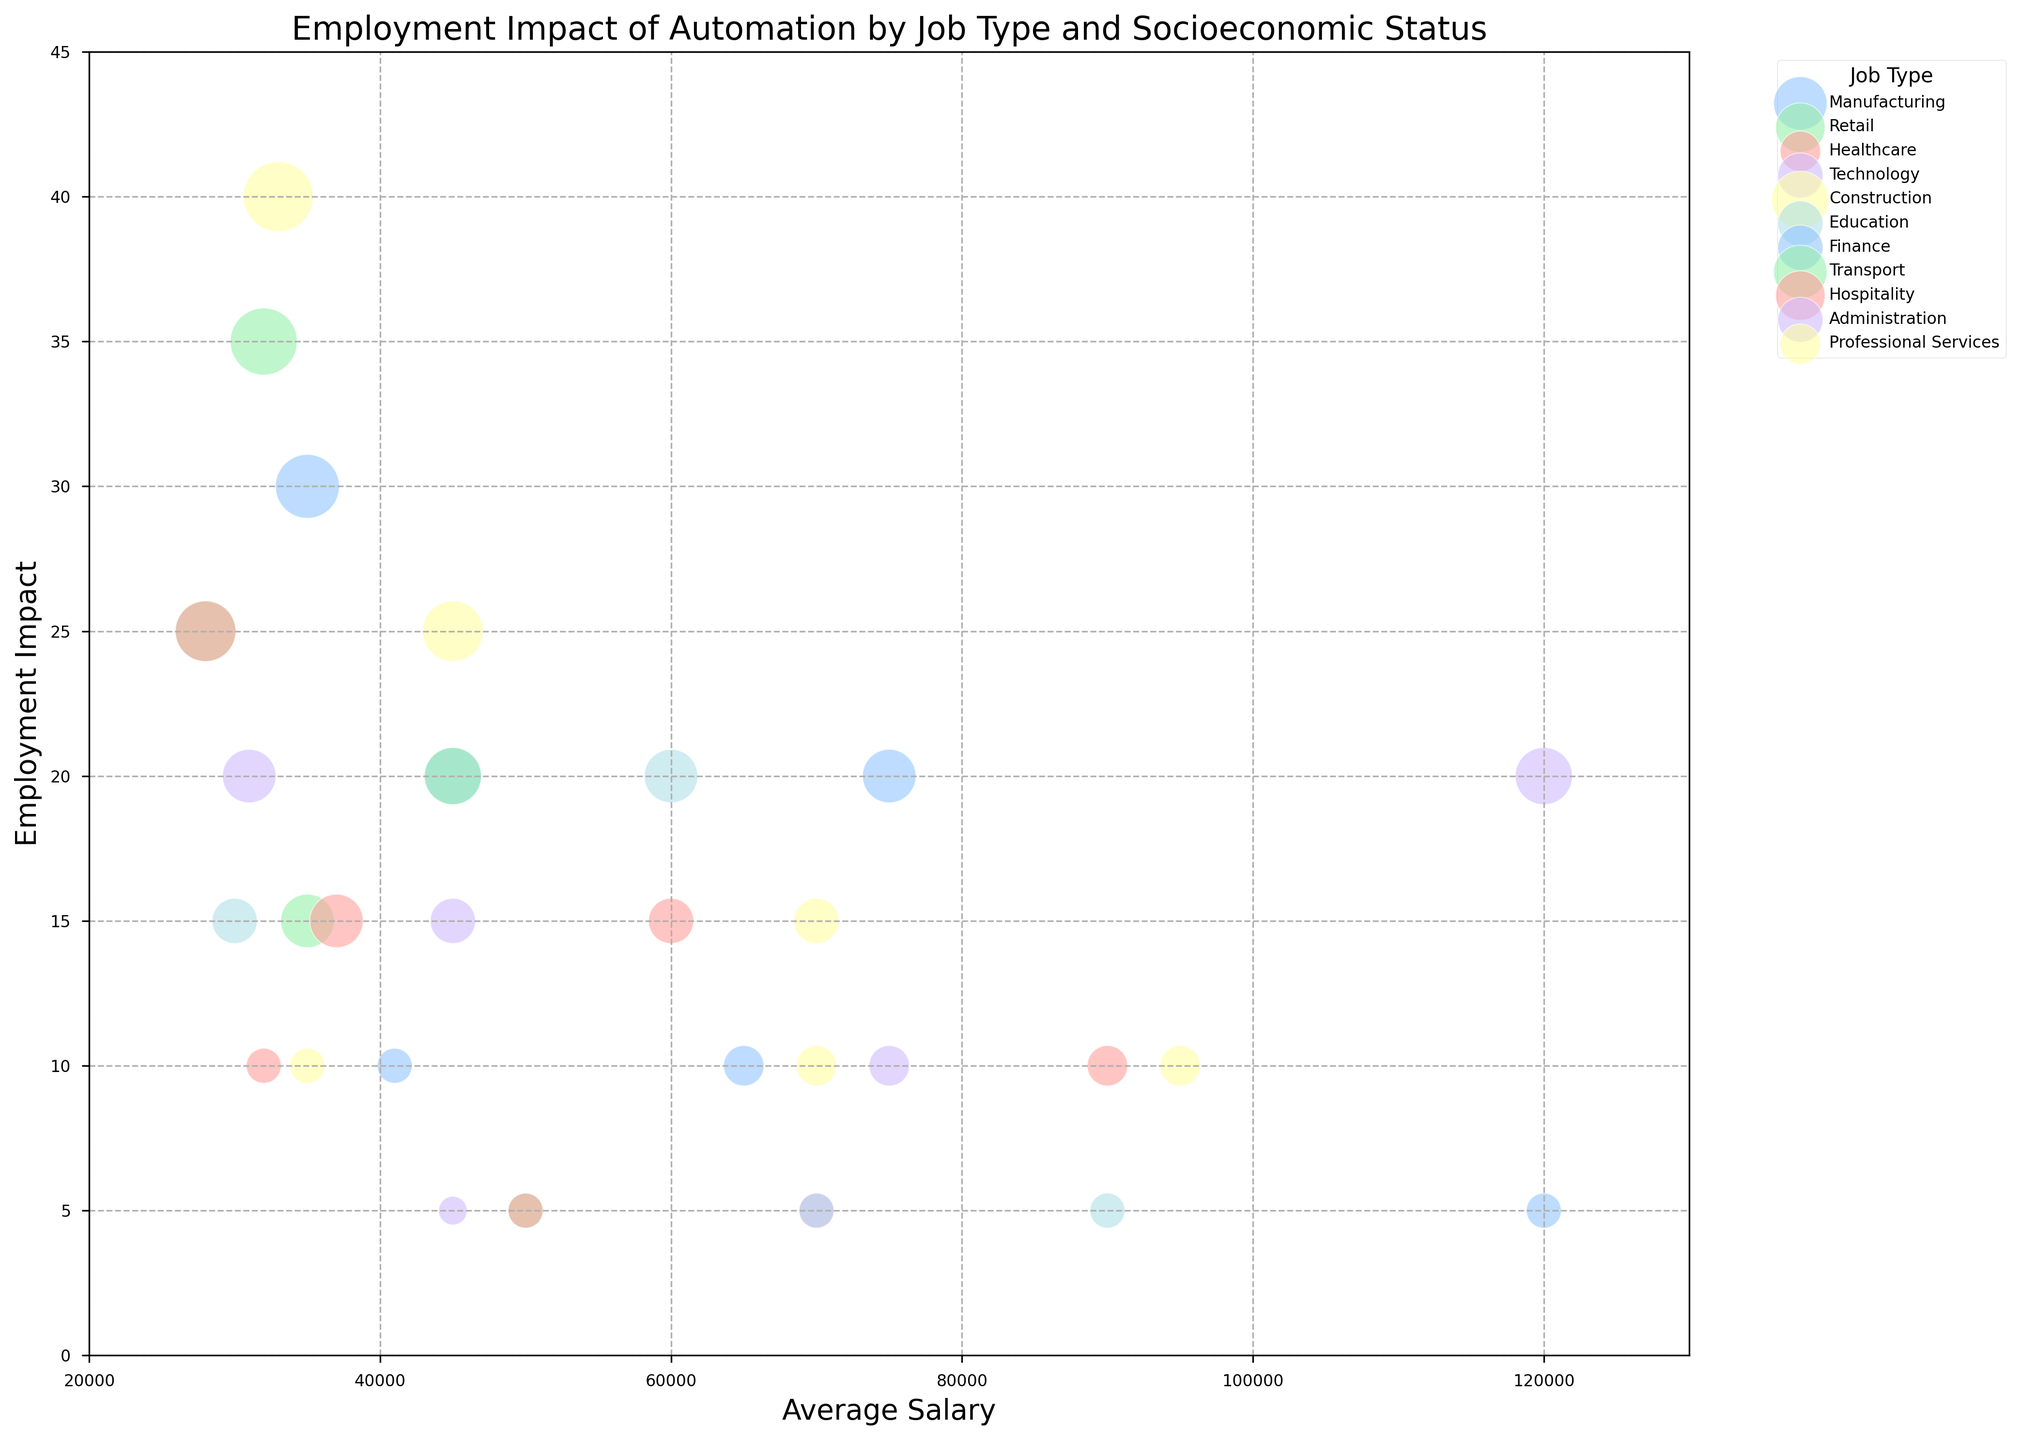Which job type has the highest employment impact overall? By visually examining the highest points on the y-axis, we observe that "Construction" has the highest employment impact at 40 for the Low socioeconomic status group.
Answer: Construction For the Low socioeconomic status groups, which job type has the largest bubble size, indicating the number of people employed in that sector? By comparing the bubble sizes for the Low socioeconomic status groups, we see that "Construction" has the largest bubble size with a value of 120.
Answer: Construction Which job type among those with High socioeconomic status experienced the least employment impact? By locating the highest socioeconomic status groups and determining the lowest points on the y-axis, "Retail", "Finance", "Transport", "Hospitality", "Administration", "Education" all have the least employment impact at 5.
Answer: Retail, Finance, Transport, Hospitality, Administration, Education What is the difference in average salary between the Low and High socioeconomic status groups within the Healthcare job type? The average salary for the Low group is 32,000, and for the High group, it is 90,000. The difference between these two values is calculated as 90,000 - 32,000 = 58,000.
Answer: 58,000 Which job type shows the widest range of employment impact across all socioeconomic statuses? By examining the y-axis range for each job type, "Construction" spans from 10 to 40, indicating the widest range of 40 - 10 = 30.
Answer: Construction For the Medium socioeconomic status groups, which job type has the highest employment impact, and what is its average salary? By identifying the highest points for the Medium socioeconomic status groups, "Construction" has the highest employment impact at 25 with an average salary of 45,000.
Answer: Construction, 45,000 Is there a job type where the High socioeconomic status group has a higher employment impact than the Low or Medium groups? By observing the plotted data, "Technology" is the only job type where the High socioeconomic status group, with an employment impact of 20, has a higher impact than the Low group with 5 and Medium group with 10.
Answer: Technology What is the average employment impact of the Low socioeconomic status groups across all job types? To calculate the average: (30 + 25 + 10 + 5 + 40 + 15 + 10 + 35 + 25 + 20 + 10) / 11 = 21.82. Summing all employment impacts and dividing by the number of job types yields the average.
Answer: 21.82 Which job types have an employment impact of 15 for the Medium socioeconomic status groups? By scanning the data points for the Medium socioeconomic status groups, "Retail", "Healthcare", "Education", "Hospitality", and "Administration" all have an employment impact of 15.
Answer: Retail, Healthcare, Education, Hospitality, Administration 